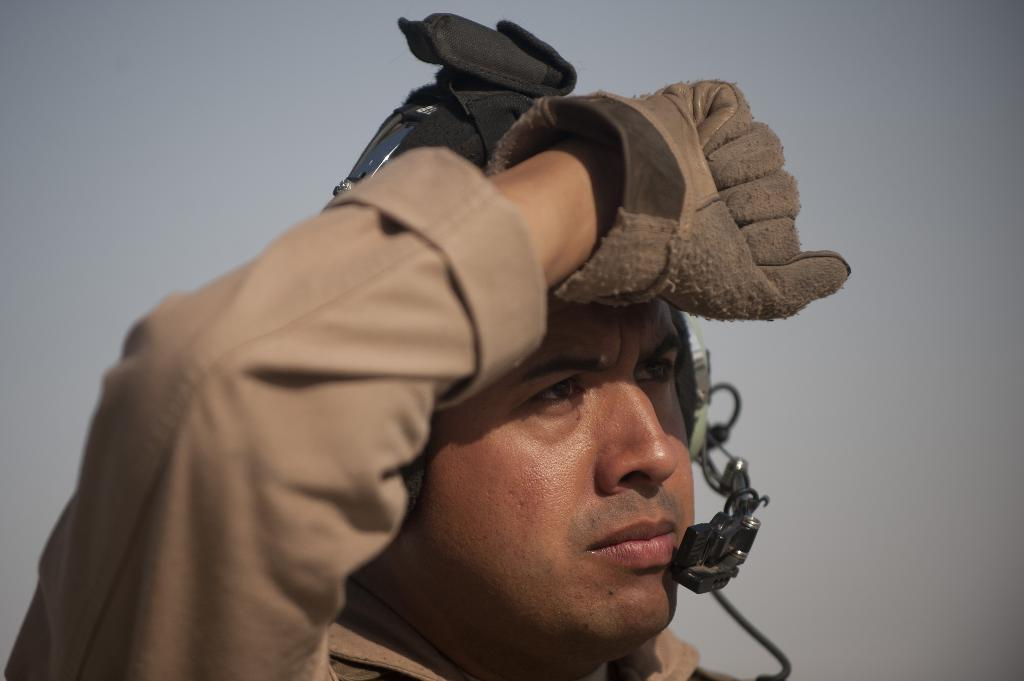What is the main subject in the foreground of the image? There is a person in the foreground of the image. What is the person wearing on their hand? The person is wearing a glove. What else can be seen in the foreground of the image besides the person? There are other objects in the foreground of the image. What color is the object in the background of the image? There is a white object in the background of the image. Can you tell me how many snakes are slithering in the middle of the image? There are no snakes present in the image, and therefore no such activity can be observed. 